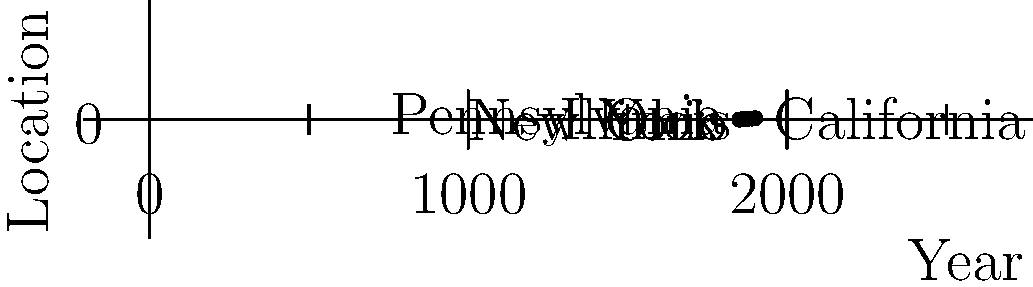Based on the graph representing an ancestor's migration pattern derived from historical census records, what can be inferred about their westward movement between 1880 and 1900? To analyze the ancestor's westward movement between 1880 and 1900, let's follow these steps:

1. Identify the location in 1880:
   - In 1880, the ancestor is shown to be in Illinois (3rd level on the y-axis).

2. Observe the pattern between 1880 and 1890:
   - The line remains flat between 1880 and 1890, indicating no change in location.
   - This suggests the ancestor stayed in Illinois during this decade.

3. Analyze the movement between 1890 and 1900:
   - There's a sharp increase in the y-axis value from 3 to 4.
   - This indicates a significant westward movement.

4. Identify the final location in 1900:
   - In 1900, the ancestor is shown to be in California (4th level on the y-axis).

5. Consider the historical context:
   - The movement from Illinois to California represents a significant westward migration.
   - This aligns with the broader trend of westward expansion in the United States during the late 19th century.

6. Infer the nature of the movement:
   - The graph shows a sudden jump rather than gradual progression.
   - This suggests a direct move from Illinois to California, likely in a single migration event.

Based on this analysis, we can infer that the ancestor made a significant westward move directly from Illinois to California between 1890 and 1900, after a period of stability in Illinois from 1880 to 1890.
Answer: Direct migration from Illinois to California between 1890 and 1900 